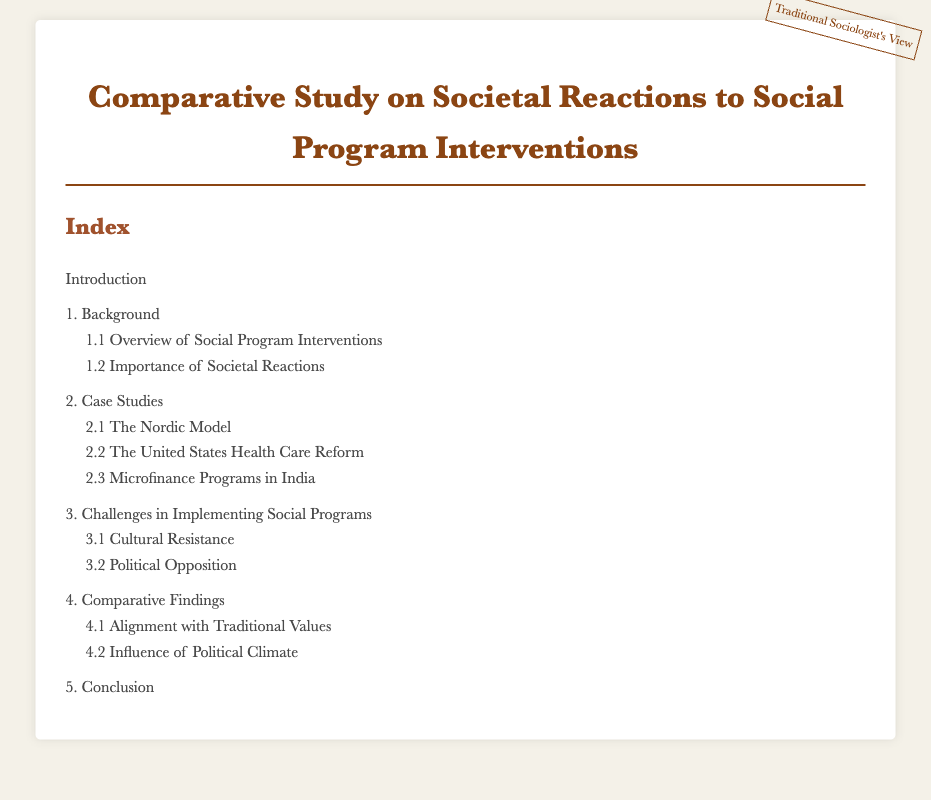What is the title of the document? The title is stated in the header section of the document, which is "Comparative Study on Societal Reactions to Social Program Interventions."
Answer: Comparative Study on Societal Reactions to Social Program Interventions What is the first section listed in the index? The first section listed in the index is found at the top under index items, which is "Introduction."
Answer: Introduction How many case studies are mentioned in the document? The number of case studies is found in the section titles under "Case Studies," which list three different studies.
Answer: 3 What is the significance of societal reactions according to the index? The significance is referenced in the "Importance of Societal Reactions" subsection under the background section.
Answer: Importance of Societal Reactions Which model is mentioned in the case studies? The model is mentioned specifically in the subsection titled "The Nordic Model."
Answer: The Nordic Model What challenges are highlighted in the document? The challenges are outlined in the "Challenges in Implementing Social Programs" section, specifically mentioning two subcategories.
Answer: Cultural Resistance, Political Opposition What is the last section of the index? The last section is located at the bottom of the index and is titled "Conclusion."
Answer: Conclusion What influences are discussed in the comparative findings? The influences are listed under the "Comparative Findings" section and include two subcategories related to values and climate.
Answer: Alignment with Traditional Values, Influence of Political Climate 